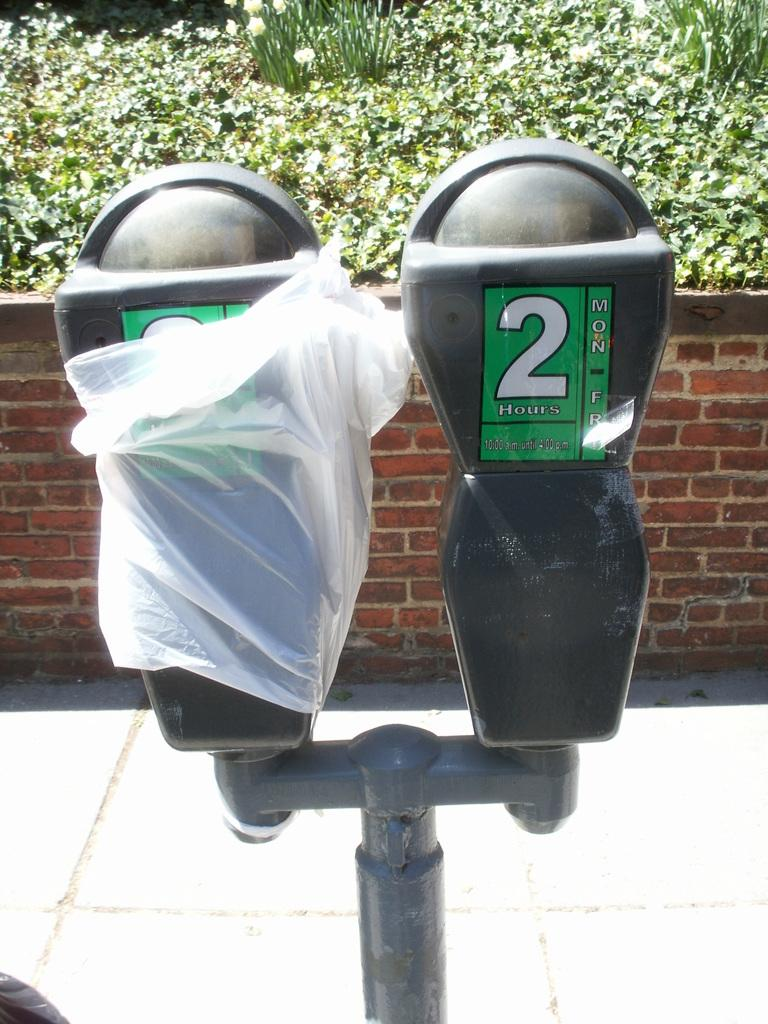<image>
Present a compact description of the photo's key features. Two parking meters are side by side and the one on the right only allows for 2 hour parking. 